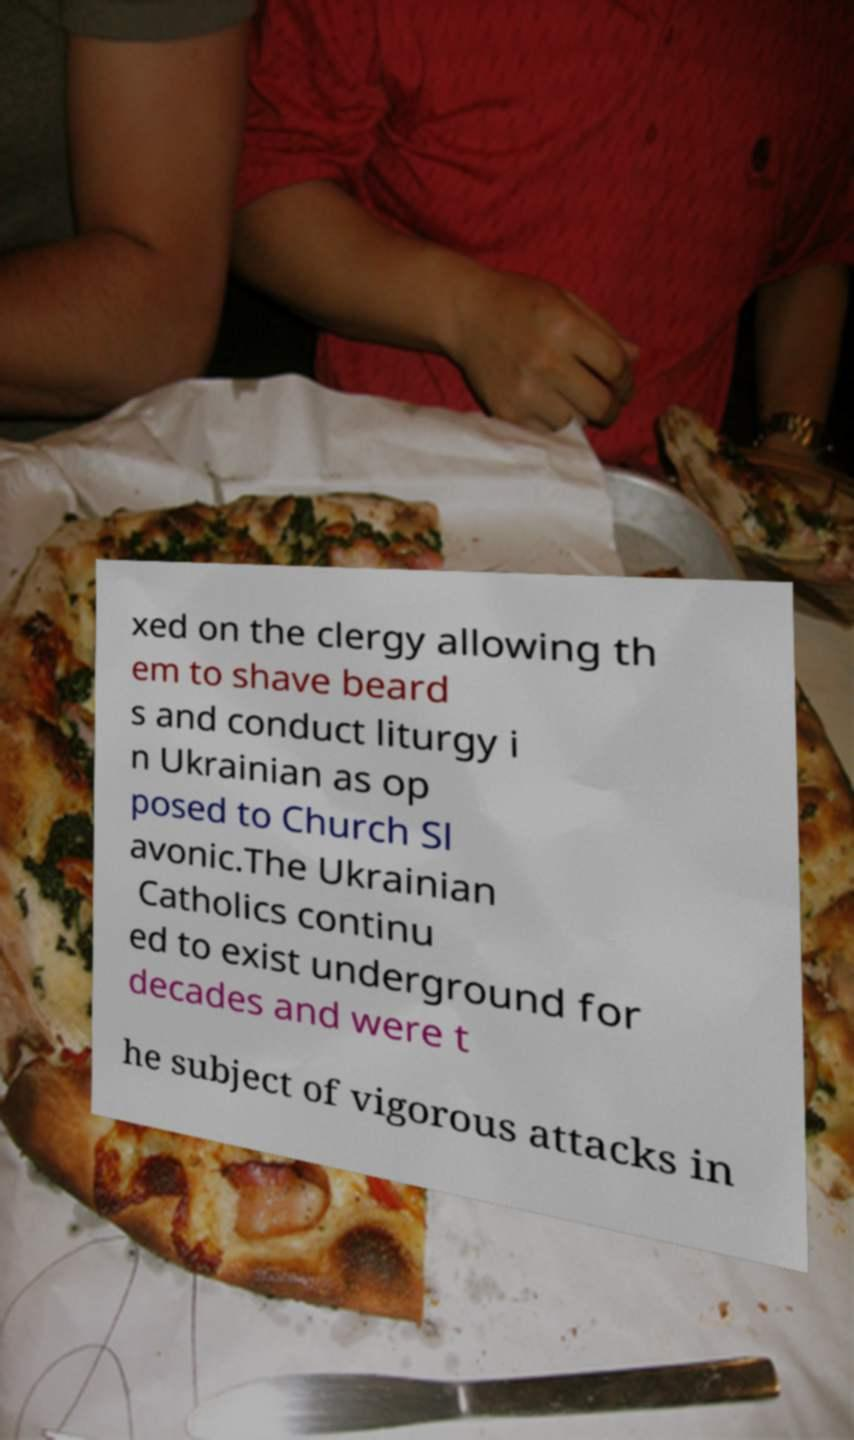Please identify and transcribe the text found in this image. xed on the clergy allowing th em to shave beard s and conduct liturgy i n Ukrainian as op posed to Church Sl avonic.The Ukrainian Catholics continu ed to exist underground for decades and were t he subject of vigorous attacks in 